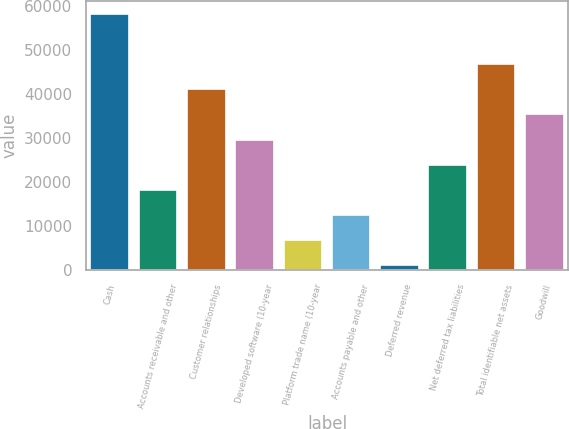Convert chart. <chart><loc_0><loc_0><loc_500><loc_500><bar_chart><fcel>Cash<fcel>Accounts receivable and other<fcel>Customer relationships<fcel>Developed software (10-year<fcel>Platform trade name (10-year<fcel>Accounts payable and other<fcel>Deferred revenue<fcel>Net deferred tax liabilities<fcel>Total identifiable net assets<fcel>Goodwill<nl><fcel>58150<fcel>18242.3<fcel>41046.7<fcel>29644.5<fcel>6840.1<fcel>12541.2<fcel>1139<fcel>23943.4<fcel>46747.8<fcel>35345.6<nl></chart> 